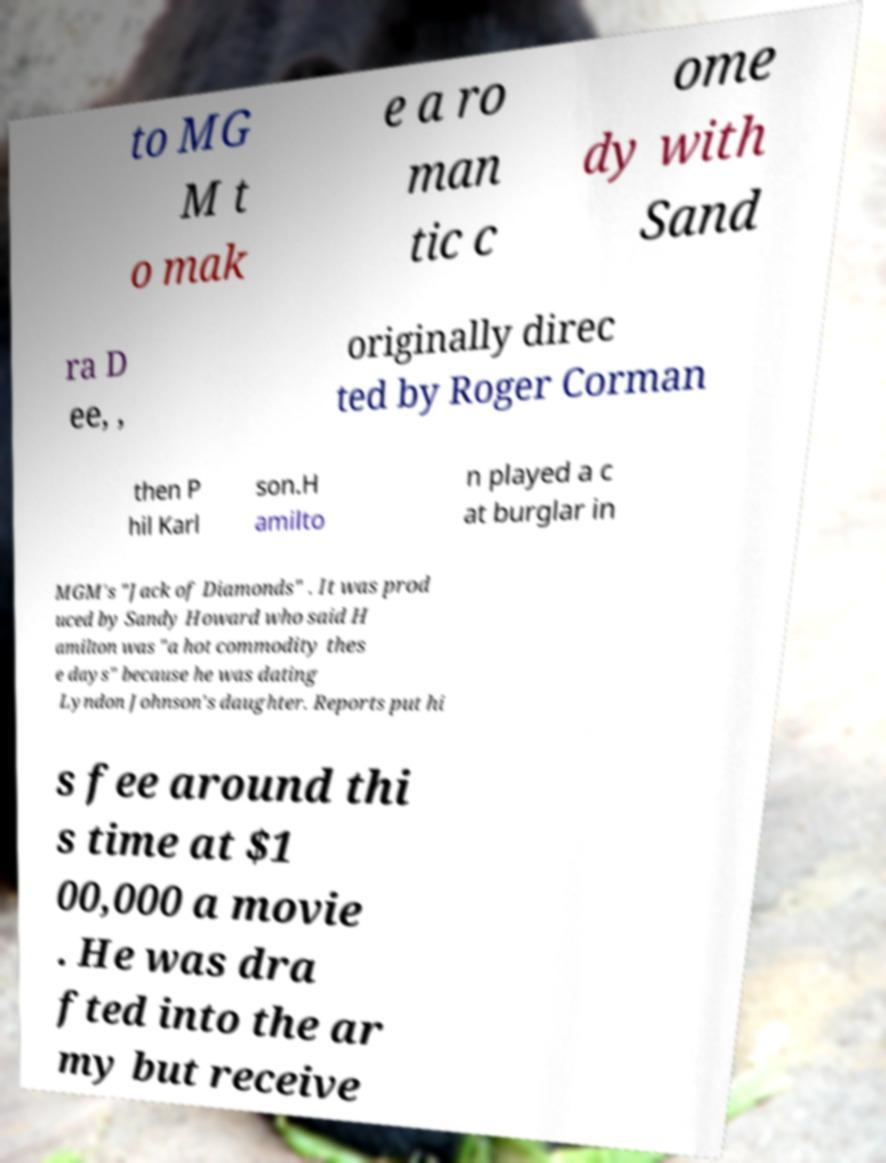There's text embedded in this image that I need extracted. Can you transcribe it verbatim? to MG M t o mak e a ro man tic c ome dy with Sand ra D ee, , originally direc ted by Roger Corman then P hil Karl son.H amilto n played a c at burglar in MGM's "Jack of Diamonds" . It was prod uced by Sandy Howard who said H amilton was "a hot commodity thes e days" because he was dating Lyndon Johnson's daughter. Reports put hi s fee around thi s time at $1 00,000 a movie . He was dra fted into the ar my but receive 